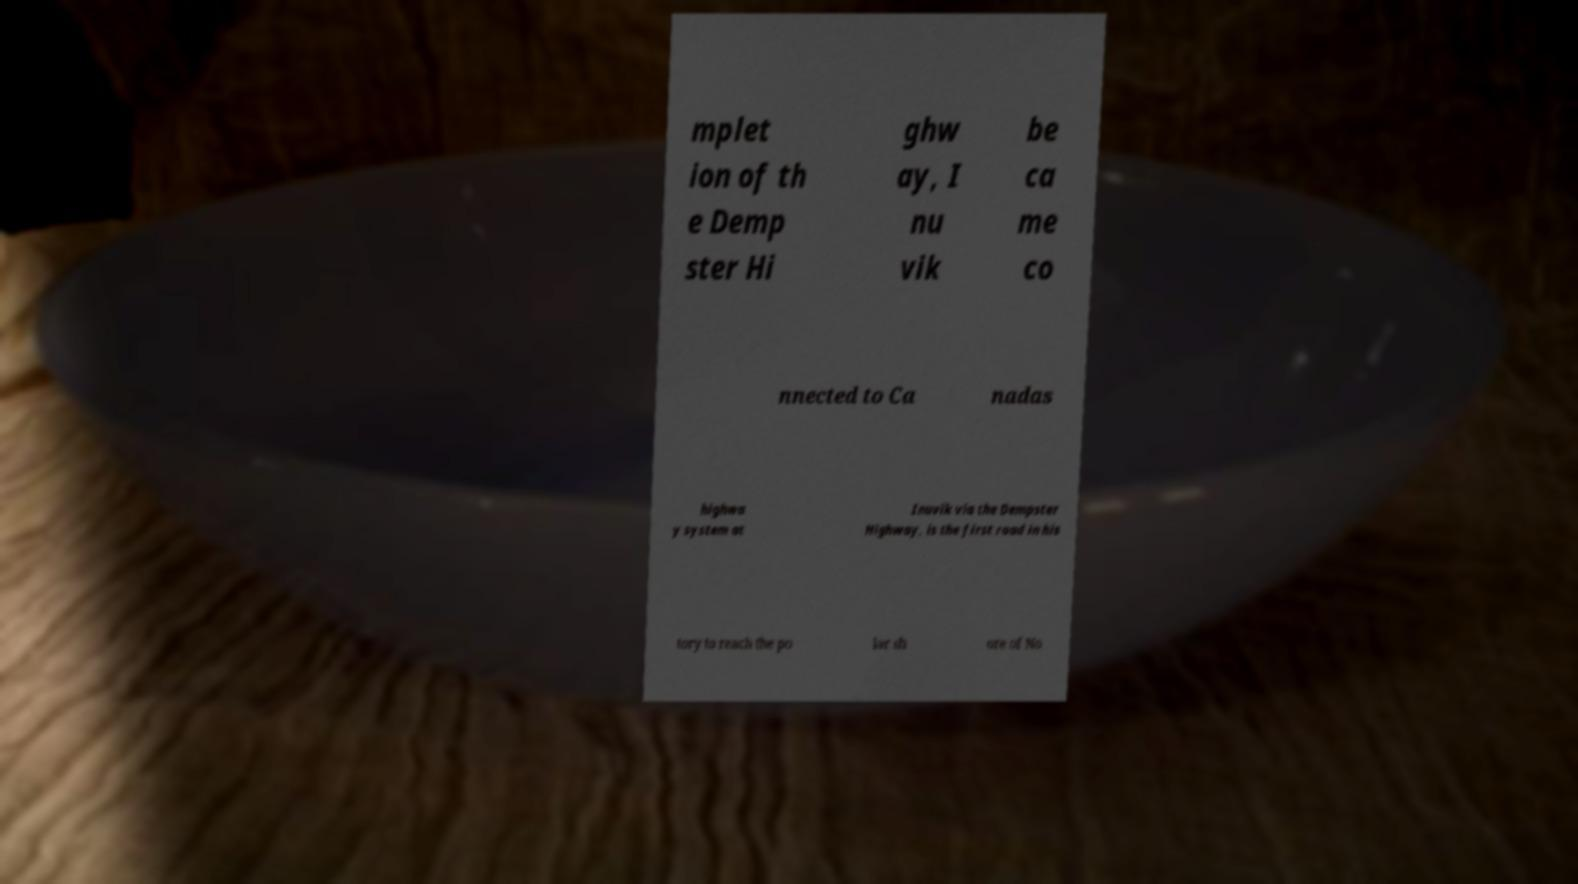There's text embedded in this image that I need extracted. Can you transcribe it verbatim? mplet ion of th e Demp ster Hi ghw ay, I nu vik be ca me co nnected to Ca nadas highwa y system at Inuvik via the Dempster Highway, is the first road in his tory to reach the po lar sh ore of No 